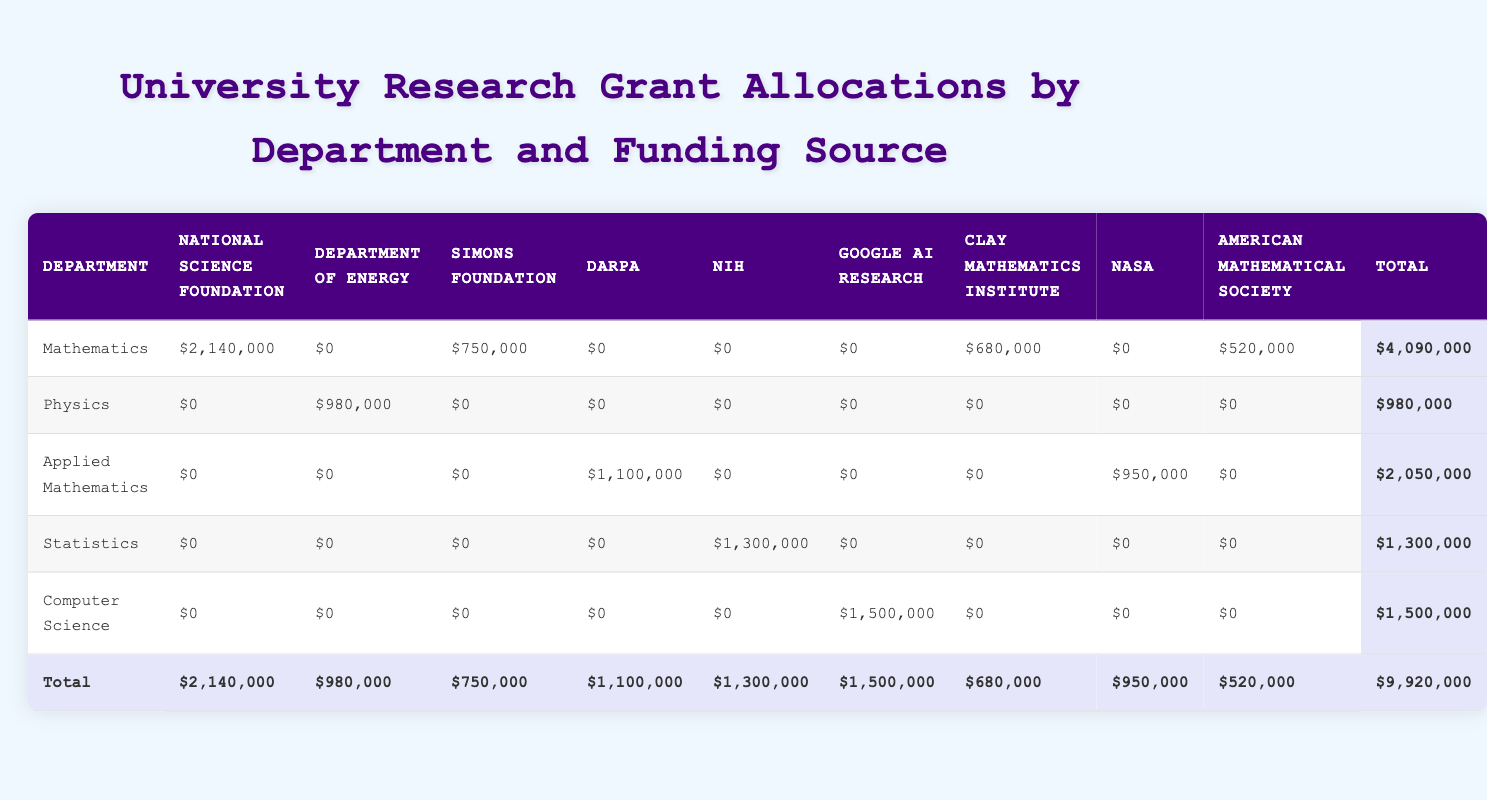Which department received the highest total grant amount? Looking at the total column in the table, the department with the highest total amount is Mathematics, which received $4,090,000.
Answer: Mathematics What is the total amount of grants received by the Applied Mathematics department? In the Applied Mathematics row, the total grant amount is listed as $2,050,000.
Answer: $2,050,000 Did the Physics department receive any grants from the National Science Foundation? By examining the row for Physics, the amount listed under the National Science Foundation is $0, indicating that they did not receive any grants from this funding source.
Answer: No What is the sum of the grants received by the Statistics and Applied Mathematics departments? The total for Statistics is $1,300,000 and for Applied Mathematics is $2,050,000. Adding these together gives $1,300,000 + $2,050,000 = $3,350,000.
Answer: $3,350,000 Is it true that the Computer Science department received less than $1,000,000 in grants? The total grant amount for the Computer Science department is $1,500,000, which is greater than $1,000,000. Thus, this statement is false.
Answer: No What percentage of the total grants allocated came from the NIH? The total of grants from the NIH is $1,300,000. Since the overall total grants listed is $9,920,000, the percentage is calculated as (1,300,000 / 9,920,000) * 100 = approximately 13.12%.
Answer: 13.12% Which funding source provided the largest single grant amount to the University of Chicago's Mathematics department? The row for the University of Chicago’s Mathematics department shows that they received a grant from the American Mathematical Society amounting to $520,000, which is their only grant recorded in the table.
Answer: American Mathematical Society How much more did MIT’s Computer Science department receive compared to the Department of Energy received by Stanford? MIT’s Computer Science department obtained $1,500,000 and Stanford received $980,000 from the Department of Energy. The difference is $1,500,000 - $980,000 = $520,000.
Answer: $520,000 How many departments received funding from the National Science Foundation? By examining the table, both the Mathematics department at MIT and Princeton received funding from the National Science Foundation. Therefore, two departments were funded by this source.
Answer: 2 